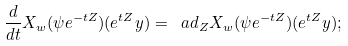Convert formula to latex. <formula><loc_0><loc_0><loc_500><loc_500>\frac { d } { d t } X _ { w } ( \psi e ^ { - t Z } ) ( e ^ { t Z } y ) = \ a d _ { Z } X _ { w } ( \psi e ^ { - t Z } ) ( e ^ { t Z } y ) ;</formula> 